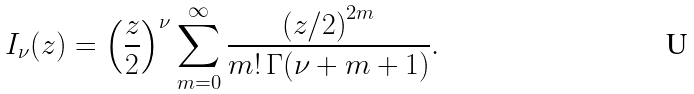<formula> <loc_0><loc_0><loc_500><loc_500>I _ { \nu } ( z ) = { \left ( \frac { z } { 2 } \right ) } ^ { \nu } \sum _ { m = 0 } ^ { \infty } \frac { { ( z / 2 ) } ^ { 2 m } } { m ! \, \Gamma ( \nu + m + 1 ) } .</formula> 